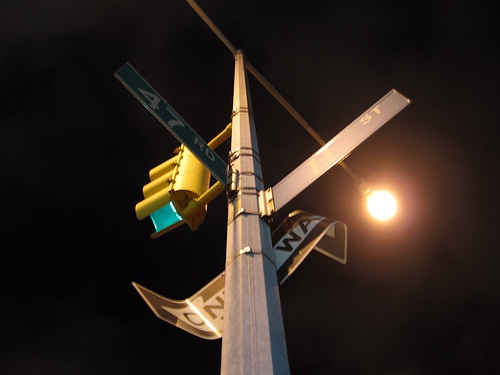Describe the objects in this image and their specific colors. I can see a traffic light in black, maroon, and olive tones in this image. 